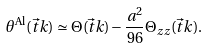<formula> <loc_0><loc_0><loc_500><loc_500>\theta ^ { \text {Al} } ( \vec { t } { k } ) \simeq \Theta ( \vec { t } { k } ) - \frac { a ^ { 2 } } { 9 6 } \Theta _ { z z } ( \vec { t } { k } ) .</formula> 